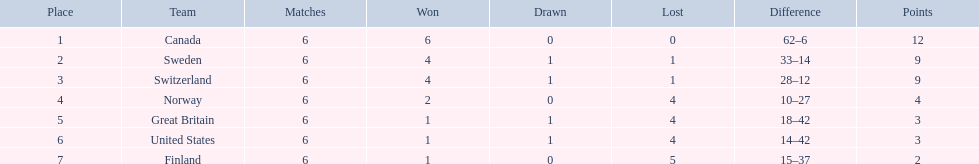What are all the groups? Canada, Sweden, Switzerland, Norway, Great Britain, United States, Finland. What were their scores? 12, 9, 9, 4, 3, 3, 2. What about specifically switzerland and great britain? 9, 3. Now, which of those teams had a higher score? Switzerland. 